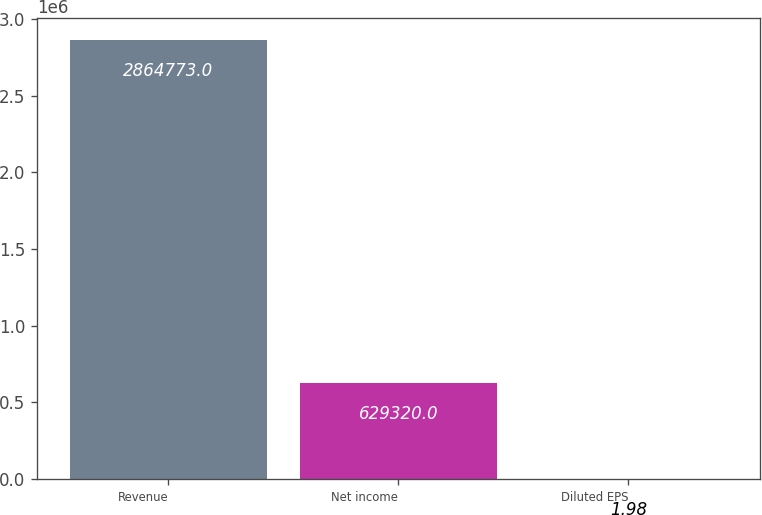<chart> <loc_0><loc_0><loc_500><loc_500><bar_chart><fcel>Revenue<fcel>Net income<fcel>Diluted EPS<nl><fcel>2.86477e+06<fcel>629320<fcel>1.98<nl></chart> 